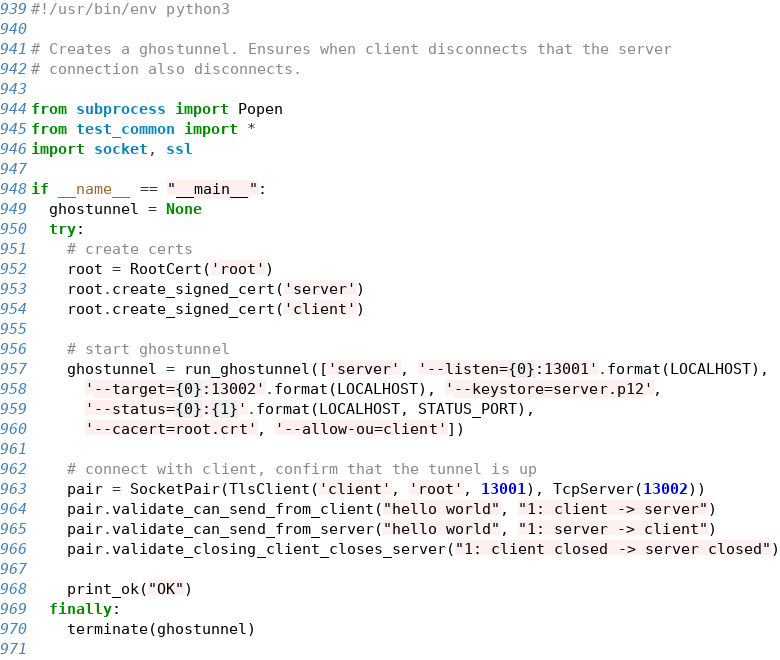Convert code to text. <code><loc_0><loc_0><loc_500><loc_500><_Python_>#!/usr/bin/env python3

# Creates a ghostunnel. Ensures when client disconnects that the server
# connection also disconnects.

from subprocess import Popen
from test_common import *
import socket, ssl

if __name__ == "__main__":
  ghostunnel = None
  try:
    # create certs
    root = RootCert('root')
    root.create_signed_cert('server')
    root.create_signed_cert('client')

    # start ghostunnel
    ghostunnel = run_ghostunnel(['server', '--listen={0}:13001'.format(LOCALHOST),
      '--target={0}:13002'.format(LOCALHOST), '--keystore=server.p12',
      '--status={0}:{1}'.format(LOCALHOST, STATUS_PORT),
      '--cacert=root.crt', '--allow-ou=client'])

    # connect with client, confirm that the tunnel is up
    pair = SocketPair(TlsClient('client', 'root', 13001), TcpServer(13002))
    pair.validate_can_send_from_client("hello world", "1: client -> server")
    pair.validate_can_send_from_server("hello world", "1: server -> client")
    pair.validate_closing_client_closes_server("1: client closed -> server closed")

    print_ok("OK")
  finally:
    terminate(ghostunnel)
      
</code> 